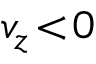<formula> <loc_0><loc_0><loc_500><loc_500>v _ { z } \, < \, 0</formula> 